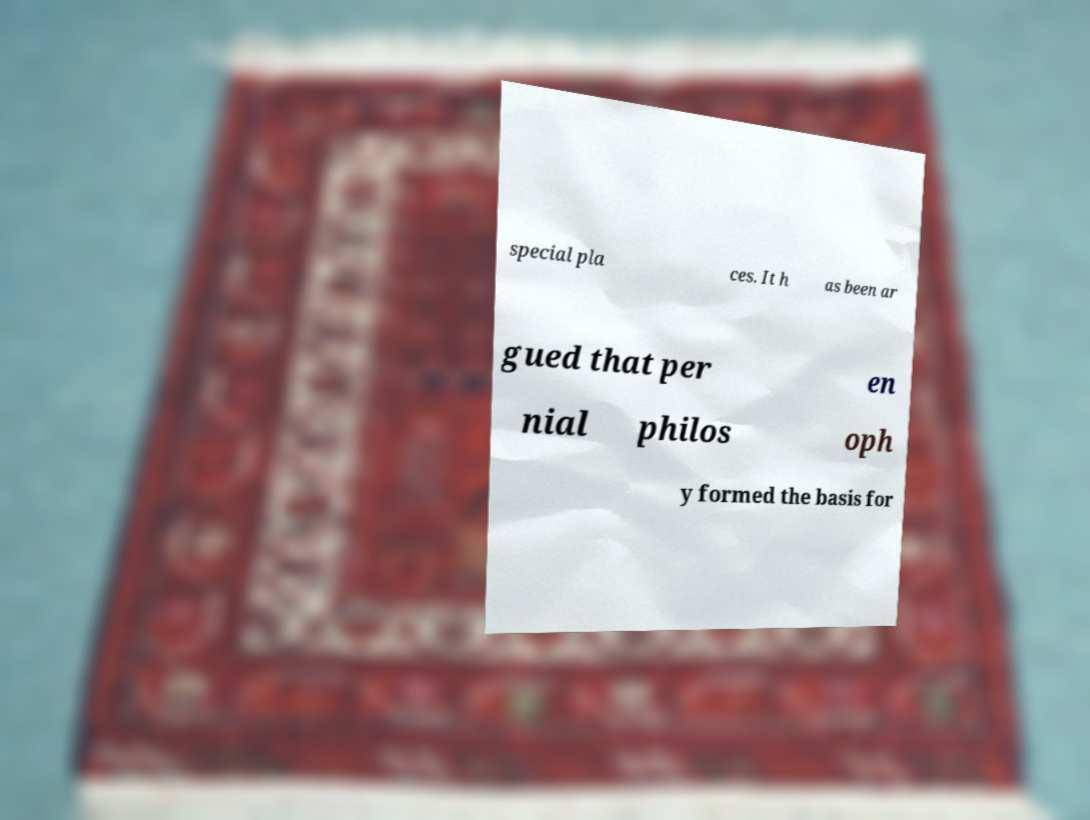Please read and relay the text visible in this image. What does it say? special pla ces. It h as been ar gued that per en nial philos oph y formed the basis for 